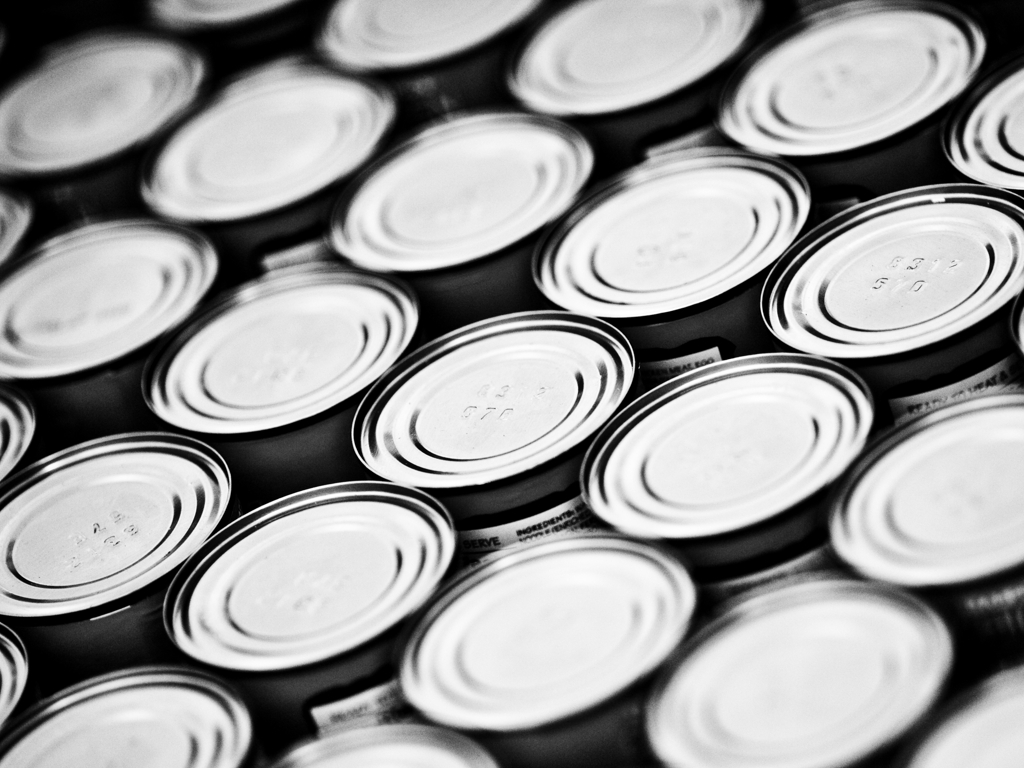Is there some blur around the edges? Yes, upon close inspection, there is indeed a subtle blur around the edges of the image. This effect often occurs due to the depth of field created by the camera's lens, which can cause the periphery of a photograph to appear less sharp than the central focus area. The blur adds a sense of depth to the image, emphasizing the central subject matter. 